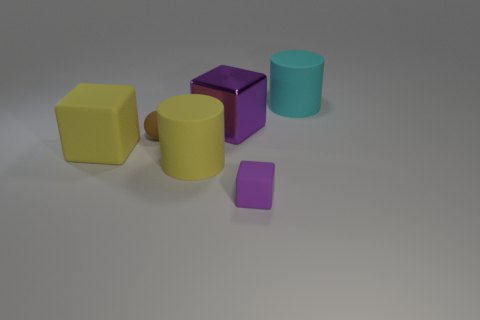What is the shape of the thing that is the same color as the large matte cube?
Make the answer very short. Cylinder. What material is the small brown object that is left of the large rubber cylinder in front of the large matte thing on the right side of the purple rubber block?
Keep it short and to the point. Rubber. Does the big purple thing that is on the right side of the matte ball have the same shape as the tiny purple thing?
Make the answer very short. Yes. There is a purple thing behind the purple rubber cube; what is its material?
Offer a terse response. Metal. What number of metallic things are green balls or tiny blocks?
Provide a succinct answer. 0. Are there any objects that have the same size as the cyan rubber cylinder?
Your answer should be compact. Yes. Is the number of big objects that are left of the brown rubber ball greater than the number of big brown objects?
Your answer should be compact. Yes. What number of big objects are either gray cylinders or purple blocks?
Ensure brevity in your answer.  1. How many small matte objects are the same shape as the large purple object?
Your answer should be very brief. 1. What material is the large cube that is on the right side of the big rubber cylinder left of the tiny purple thing made of?
Make the answer very short. Metal. 